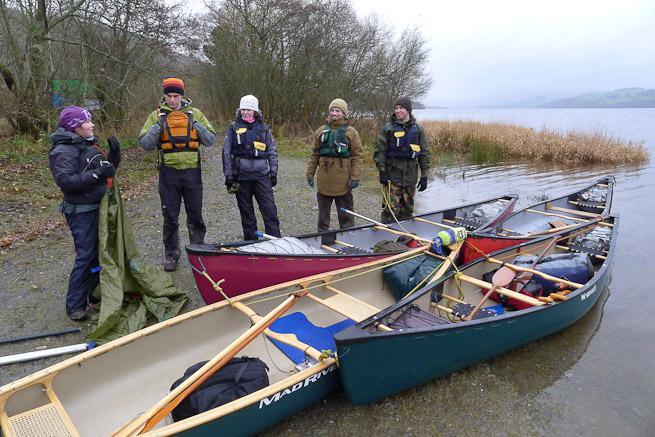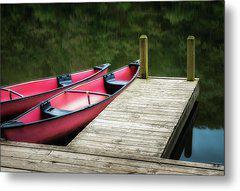The first image is the image on the left, the second image is the image on the right. Evaluate the accuracy of this statement regarding the images: "There are a minimum of four boats.". Is it true? Answer yes or no. Yes. The first image is the image on the left, the second image is the image on the right. Given the left and right images, does the statement "One image shows side-by-side canoes joined with just two simple poles and not floating on water." hold true? Answer yes or no. No. 